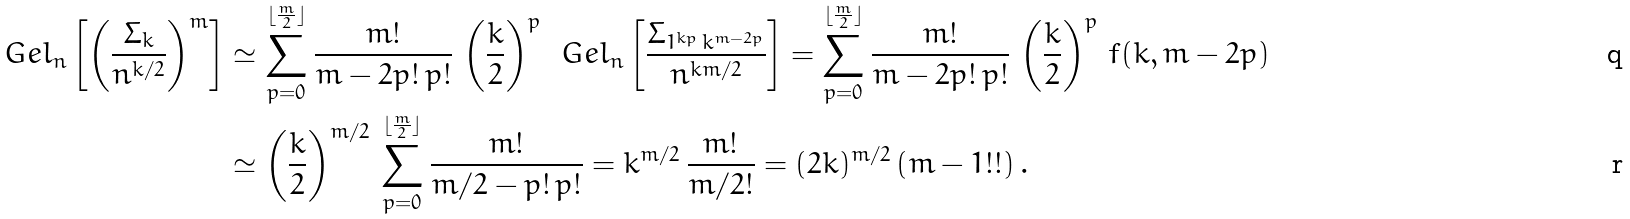Convert formula to latex. <formula><loc_0><loc_0><loc_500><loc_500>\ G e l _ { n } \left [ \left ( \frac { \varSigma _ { k } } { n ^ { k / 2 } } \right ) ^ { m } \right ] & \simeq \sum _ { p = 0 } ^ { \lfloor \frac { m } { 2 } \rfloor } \frac { m ! } { m - 2 p ! \, p ! } \, \left ( \frac { k } { 2 } \right ) ^ { p } \, \ G e l _ { n } \left [ \frac { \varSigma _ { 1 ^ { k p } \, k ^ { m - 2 p } } } { n ^ { k m / 2 } } \right ] = \sum _ { p = 0 } ^ { \lfloor \frac { m } { 2 } \rfloor } \frac { m ! } { m - 2 p ! \, p ! } \, \left ( \frac { k } { 2 } \right ) ^ { p } \, f ( k , m - 2 p ) \\ & \simeq \left ( \frac { k } { 2 } \right ) ^ { m / 2 } \, \sum _ { p = 0 } ^ { \lfloor \frac { m } { 2 } \rfloor } \frac { m ! } { m / 2 - p ! \, p ! } = k ^ { m / 2 } \, \frac { m ! } { m / 2 ! } = ( 2 k ) ^ { m / 2 } \, ( m - 1 ! ! ) \, .</formula> 